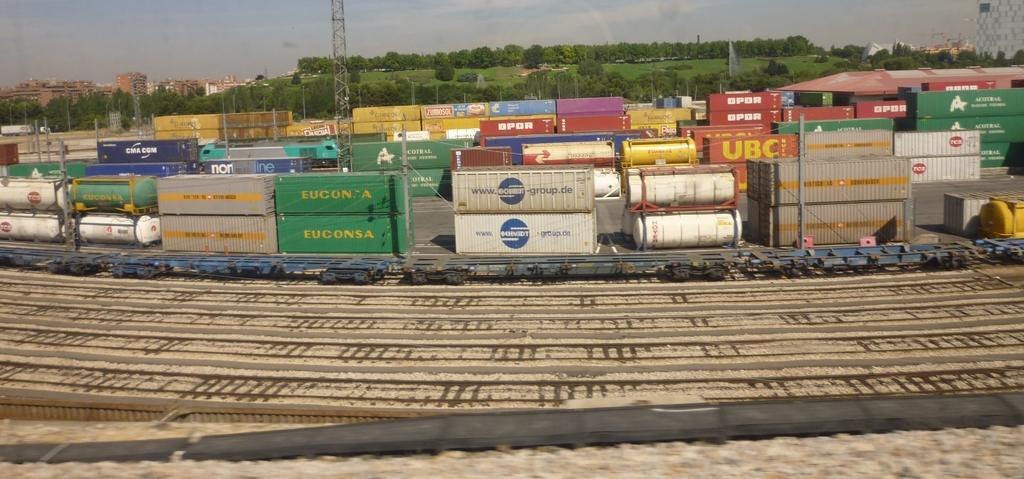Provide a one-sentence caption for the provided image. Railroad tracks show containers including a green Euconsa container. 